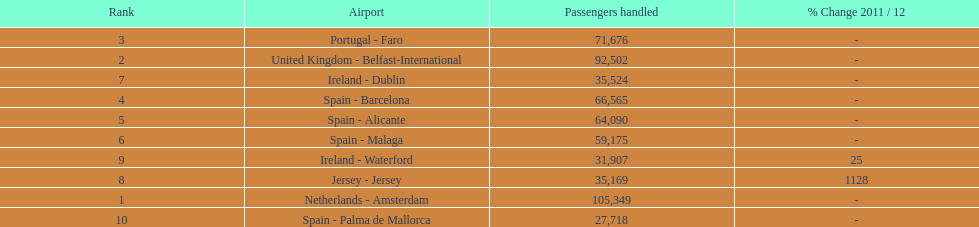What are the airports? Netherlands - Amsterdam, United Kingdom - Belfast-International, Portugal - Faro, Spain - Barcelona, Spain - Alicante, Spain - Malaga, Ireland - Dublin, Jersey - Jersey, Ireland - Waterford, Spain - Palma de Mallorca. Of these which has the least amount of passengers? Spain - Palma de Mallorca. 